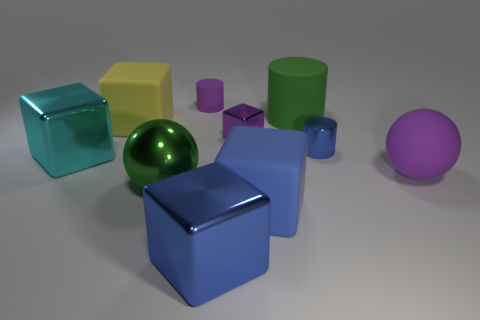Subtract 2 cubes. How many cubes are left? 3 Subtract all tiny purple shiny cubes. How many cubes are left? 4 Subtract all brown blocks. Subtract all gray cylinders. How many blocks are left? 5 Subtract all cylinders. How many objects are left? 7 Subtract 1 purple cylinders. How many objects are left? 9 Subtract all cubes. Subtract all tiny metal objects. How many objects are left? 3 Add 4 cyan objects. How many cyan objects are left? 5 Add 4 big blocks. How many big blocks exist? 8 